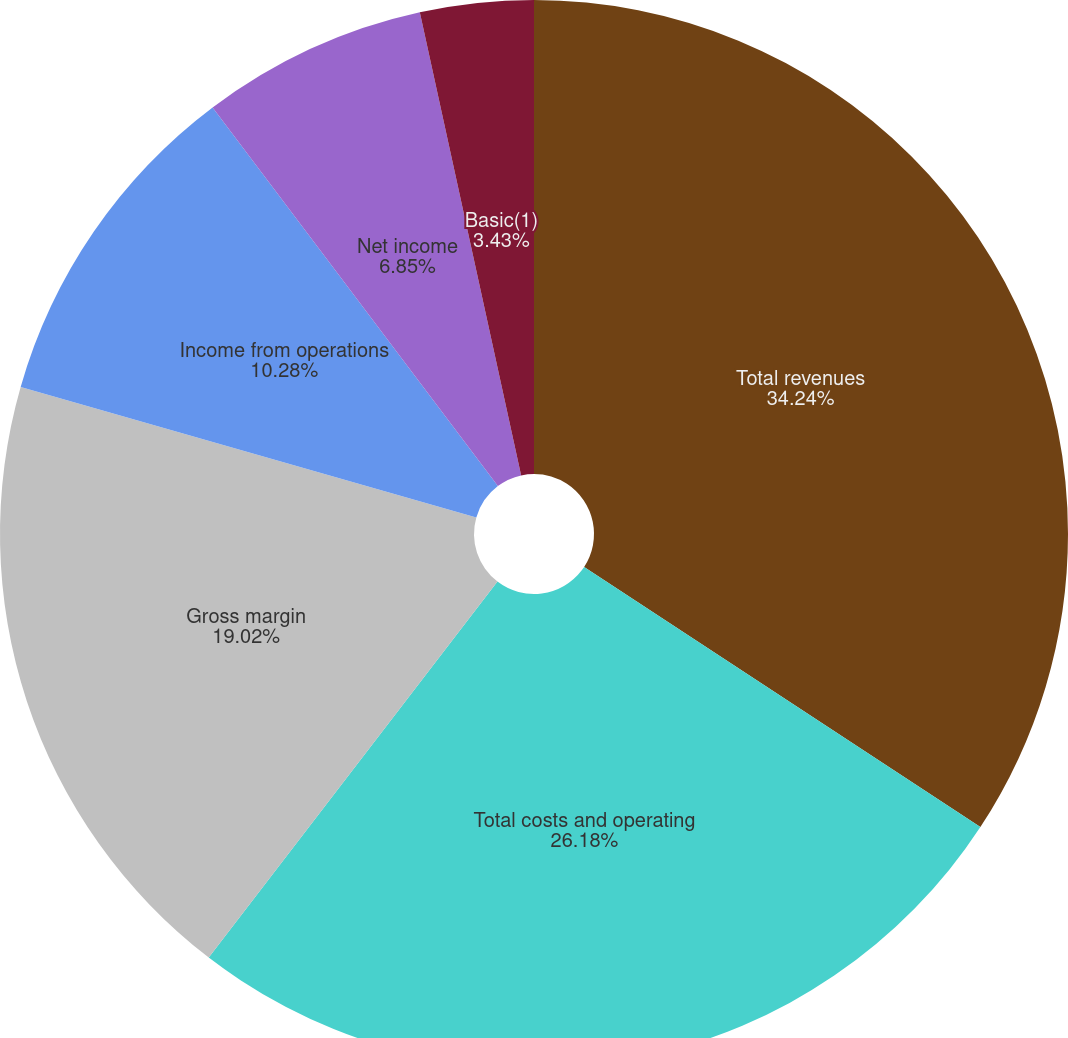Convert chart. <chart><loc_0><loc_0><loc_500><loc_500><pie_chart><fcel>Total revenues<fcel>Total costs and operating<fcel>Gross margin<fcel>Income from operations<fcel>Net income<fcel>Basic(1)<fcel>Diluted(1)<nl><fcel>34.25%<fcel>26.18%<fcel>19.02%<fcel>10.28%<fcel>6.85%<fcel>3.43%<fcel>0.0%<nl></chart> 